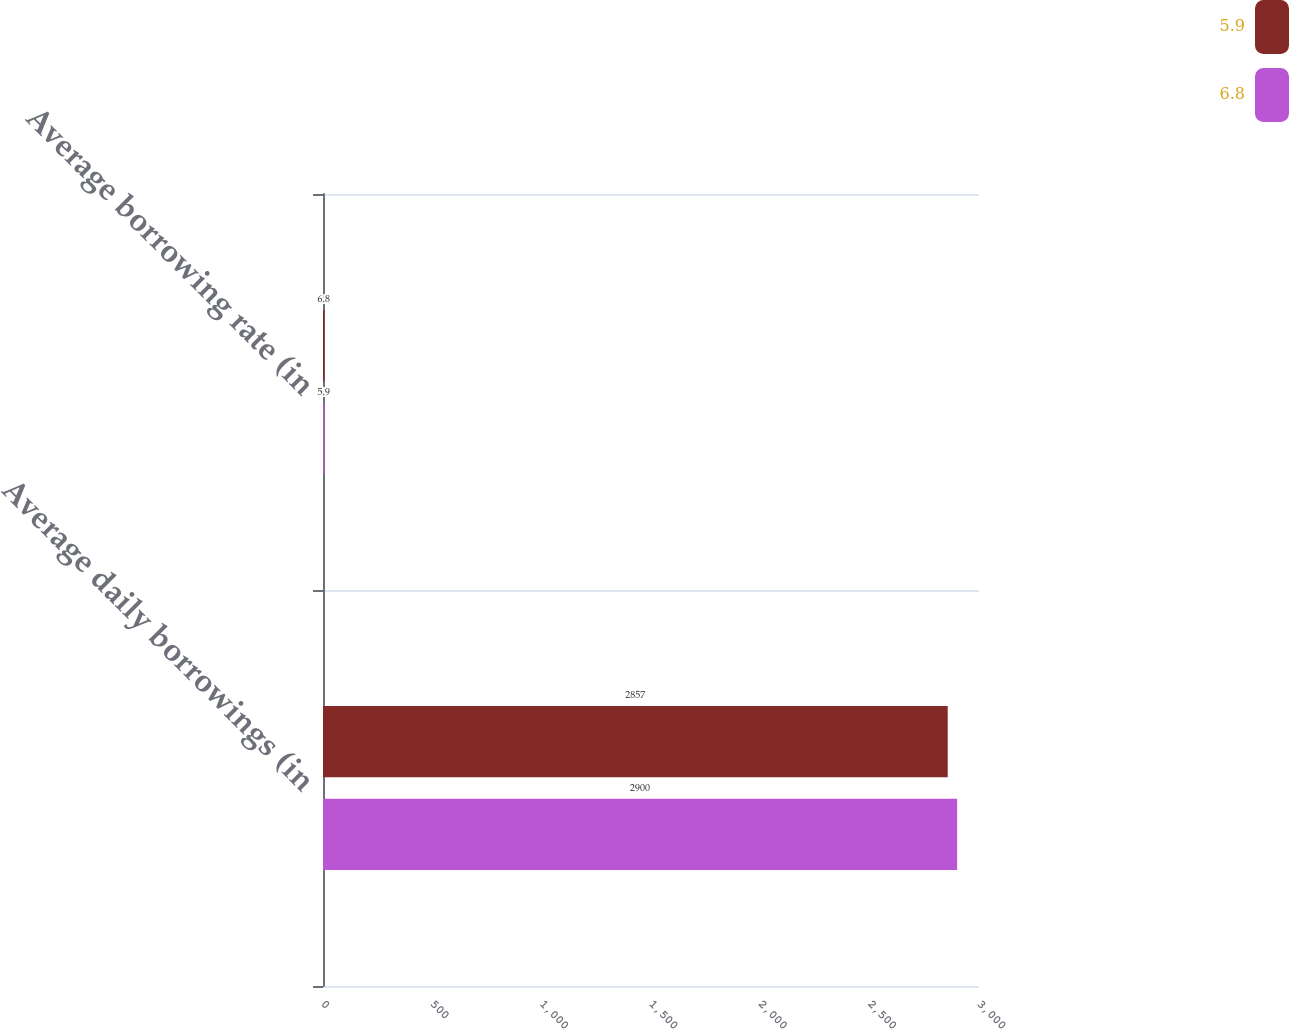<chart> <loc_0><loc_0><loc_500><loc_500><stacked_bar_chart><ecel><fcel>Average daily borrowings (in<fcel>Average borrowing rate (in<nl><fcel>5.9<fcel>2857<fcel>6.8<nl><fcel>6.8<fcel>2900<fcel>5.9<nl></chart> 